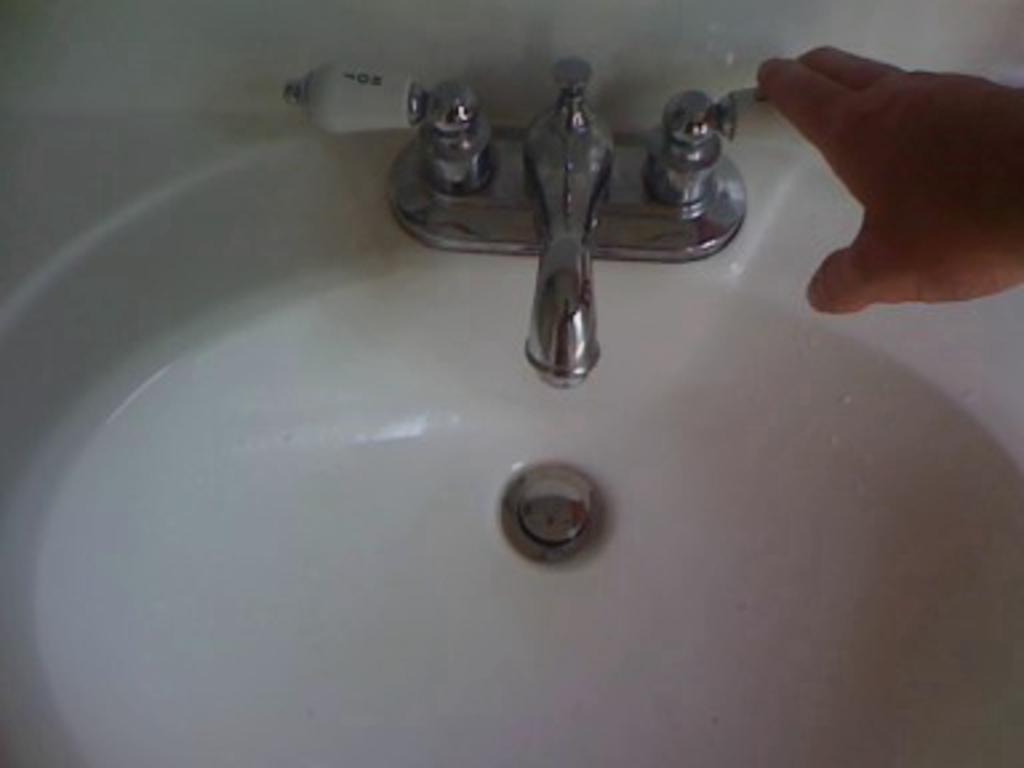What type of fixture is present in the image? There is a sink in the image. Can you describe any other elements in the image? There is a hand visible in the top right corner of the image. What type of bulb is being held by the squirrel in the image? There is no squirrel or bulb present in the image. What part of the brain is visible in the image? There is no brain visible in the image. 